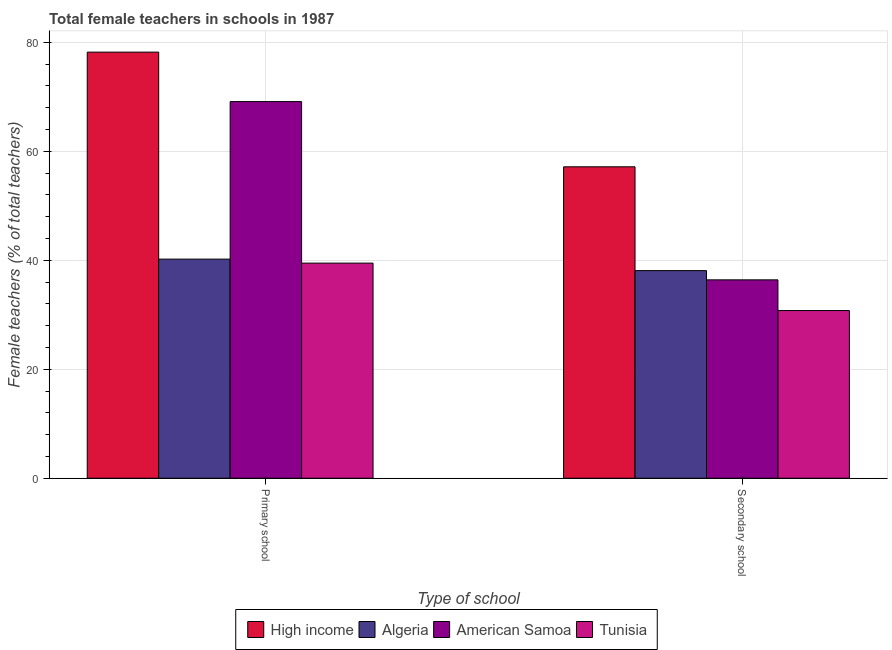Are the number of bars per tick equal to the number of legend labels?
Your response must be concise. Yes. Are the number of bars on each tick of the X-axis equal?
Provide a short and direct response. Yes. How many bars are there on the 2nd tick from the left?
Ensure brevity in your answer.  4. What is the label of the 2nd group of bars from the left?
Offer a very short reply. Secondary school. What is the percentage of female teachers in primary schools in American Samoa?
Your answer should be compact. 69.11. Across all countries, what is the maximum percentage of female teachers in primary schools?
Your answer should be compact. 78.19. Across all countries, what is the minimum percentage of female teachers in primary schools?
Your response must be concise. 39.47. In which country was the percentage of female teachers in secondary schools minimum?
Your response must be concise. Tunisia. What is the total percentage of female teachers in primary schools in the graph?
Keep it short and to the point. 226.98. What is the difference between the percentage of female teachers in secondary schools in Tunisia and that in American Samoa?
Ensure brevity in your answer.  -5.63. What is the difference between the percentage of female teachers in secondary schools in High income and the percentage of female teachers in primary schools in Tunisia?
Your answer should be very brief. 17.67. What is the average percentage of female teachers in primary schools per country?
Provide a short and direct response. 56.75. What is the difference between the percentage of female teachers in secondary schools and percentage of female teachers in primary schools in Algeria?
Your response must be concise. -2.11. What is the ratio of the percentage of female teachers in secondary schools in Algeria to that in Tunisia?
Provide a succinct answer. 1.24. Is the percentage of female teachers in primary schools in American Samoa less than that in High income?
Your answer should be very brief. Yes. What does the 4th bar from the right in Secondary school represents?
Your answer should be compact. High income. What is the difference between two consecutive major ticks on the Y-axis?
Offer a very short reply. 20. Does the graph contain grids?
Offer a terse response. Yes. Where does the legend appear in the graph?
Offer a very short reply. Bottom center. How many legend labels are there?
Your answer should be very brief. 4. How are the legend labels stacked?
Give a very brief answer. Horizontal. What is the title of the graph?
Offer a terse response. Total female teachers in schools in 1987. What is the label or title of the X-axis?
Provide a short and direct response. Type of school. What is the label or title of the Y-axis?
Your answer should be very brief. Female teachers (% of total teachers). What is the Female teachers (% of total teachers) in High income in Primary school?
Provide a short and direct response. 78.19. What is the Female teachers (% of total teachers) in Algeria in Primary school?
Provide a short and direct response. 40.21. What is the Female teachers (% of total teachers) in American Samoa in Primary school?
Provide a succinct answer. 69.11. What is the Female teachers (% of total teachers) in Tunisia in Primary school?
Your answer should be compact. 39.47. What is the Female teachers (% of total teachers) in High income in Secondary school?
Your answer should be compact. 57.15. What is the Female teachers (% of total teachers) of Algeria in Secondary school?
Offer a very short reply. 38.1. What is the Female teachers (% of total teachers) in American Samoa in Secondary school?
Make the answer very short. 36.4. What is the Female teachers (% of total teachers) in Tunisia in Secondary school?
Keep it short and to the point. 30.77. Across all Type of school, what is the maximum Female teachers (% of total teachers) in High income?
Provide a succinct answer. 78.19. Across all Type of school, what is the maximum Female teachers (% of total teachers) in Algeria?
Provide a succinct answer. 40.21. Across all Type of school, what is the maximum Female teachers (% of total teachers) of American Samoa?
Give a very brief answer. 69.11. Across all Type of school, what is the maximum Female teachers (% of total teachers) in Tunisia?
Provide a short and direct response. 39.47. Across all Type of school, what is the minimum Female teachers (% of total teachers) of High income?
Provide a short and direct response. 57.15. Across all Type of school, what is the minimum Female teachers (% of total teachers) of Algeria?
Give a very brief answer. 38.1. Across all Type of school, what is the minimum Female teachers (% of total teachers) in American Samoa?
Your answer should be compact. 36.4. Across all Type of school, what is the minimum Female teachers (% of total teachers) of Tunisia?
Offer a very short reply. 30.77. What is the total Female teachers (% of total teachers) of High income in the graph?
Make the answer very short. 135.34. What is the total Female teachers (% of total teachers) in Algeria in the graph?
Your answer should be compact. 78.3. What is the total Female teachers (% of total teachers) in American Samoa in the graph?
Make the answer very short. 105.52. What is the total Female teachers (% of total teachers) of Tunisia in the graph?
Your response must be concise. 70.24. What is the difference between the Female teachers (% of total teachers) of High income in Primary school and that in Secondary school?
Your answer should be compact. 21.04. What is the difference between the Female teachers (% of total teachers) in Algeria in Primary school and that in Secondary school?
Ensure brevity in your answer.  2.11. What is the difference between the Female teachers (% of total teachers) in American Samoa in Primary school and that in Secondary school?
Offer a very short reply. 32.71. What is the difference between the Female teachers (% of total teachers) in Tunisia in Primary school and that in Secondary school?
Provide a succinct answer. 8.7. What is the difference between the Female teachers (% of total teachers) of High income in Primary school and the Female teachers (% of total teachers) of Algeria in Secondary school?
Provide a succinct answer. 40.09. What is the difference between the Female teachers (% of total teachers) in High income in Primary school and the Female teachers (% of total teachers) in American Samoa in Secondary school?
Offer a terse response. 41.79. What is the difference between the Female teachers (% of total teachers) in High income in Primary school and the Female teachers (% of total teachers) in Tunisia in Secondary school?
Your answer should be very brief. 47.42. What is the difference between the Female teachers (% of total teachers) of Algeria in Primary school and the Female teachers (% of total teachers) of American Samoa in Secondary school?
Your answer should be compact. 3.8. What is the difference between the Female teachers (% of total teachers) of Algeria in Primary school and the Female teachers (% of total teachers) of Tunisia in Secondary school?
Your response must be concise. 9.44. What is the difference between the Female teachers (% of total teachers) of American Samoa in Primary school and the Female teachers (% of total teachers) of Tunisia in Secondary school?
Offer a terse response. 38.34. What is the average Female teachers (% of total teachers) of High income per Type of school?
Provide a succinct answer. 67.67. What is the average Female teachers (% of total teachers) in Algeria per Type of school?
Provide a short and direct response. 39.15. What is the average Female teachers (% of total teachers) of American Samoa per Type of school?
Your answer should be compact. 52.76. What is the average Female teachers (% of total teachers) of Tunisia per Type of school?
Give a very brief answer. 35.12. What is the difference between the Female teachers (% of total teachers) in High income and Female teachers (% of total teachers) in Algeria in Primary school?
Your answer should be very brief. 37.98. What is the difference between the Female teachers (% of total teachers) of High income and Female teachers (% of total teachers) of American Samoa in Primary school?
Make the answer very short. 9.07. What is the difference between the Female teachers (% of total teachers) in High income and Female teachers (% of total teachers) in Tunisia in Primary school?
Offer a terse response. 38.72. What is the difference between the Female teachers (% of total teachers) of Algeria and Female teachers (% of total teachers) of American Samoa in Primary school?
Provide a succinct answer. -28.91. What is the difference between the Female teachers (% of total teachers) of Algeria and Female teachers (% of total teachers) of Tunisia in Primary school?
Your answer should be very brief. 0.73. What is the difference between the Female teachers (% of total teachers) in American Samoa and Female teachers (% of total teachers) in Tunisia in Primary school?
Your response must be concise. 29.64. What is the difference between the Female teachers (% of total teachers) in High income and Female teachers (% of total teachers) in Algeria in Secondary school?
Your answer should be compact. 19.05. What is the difference between the Female teachers (% of total teachers) in High income and Female teachers (% of total teachers) in American Samoa in Secondary school?
Offer a terse response. 20.74. What is the difference between the Female teachers (% of total teachers) in High income and Female teachers (% of total teachers) in Tunisia in Secondary school?
Your response must be concise. 26.38. What is the difference between the Female teachers (% of total teachers) of Algeria and Female teachers (% of total teachers) of American Samoa in Secondary school?
Offer a terse response. 1.69. What is the difference between the Female teachers (% of total teachers) in Algeria and Female teachers (% of total teachers) in Tunisia in Secondary school?
Keep it short and to the point. 7.33. What is the difference between the Female teachers (% of total teachers) in American Samoa and Female teachers (% of total teachers) in Tunisia in Secondary school?
Your answer should be very brief. 5.63. What is the ratio of the Female teachers (% of total teachers) in High income in Primary school to that in Secondary school?
Offer a very short reply. 1.37. What is the ratio of the Female teachers (% of total teachers) of Algeria in Primary school to that in Secondary school?
Provide a succinct answer. 1.06. What is the ratio of the Female teachers (% of total teachers) in American Samoa in Primary school to that in Secondary school?
Offer a very short reply. 1.9. What is the ratio of the Female teachers (% of total teachers) of Tunisia in Primary school to that in Secondary school?
Your answer should be very brief. 1.28. What is the difference between the highest and the second highest Female teachers (% of total teachers) in High income?
Your answer should be compact. 21.04. What is the difference between the highest and the second highest Female teachers (% of total teachers) of Algeria?
Provide a succinct answer. 2.11. What is the difference between the highest and the second highest Female teachers (% of total teachers) of American Samoa?
Give a very brief answer. 32.71. What is the difference between the highest and the second highest Female teachers (% of total teachers) of Tunisia?
Keep it short and to the point. 8.7. What is the difference between the highest and the lowest Female teachers (% of total teachers) of High income?
Offer a terse response. 21.04. What is the difference between the highest and the lowest Female teachers (% of total teachers) in Algeria?
Ensure brevity in your answer.  2.11. What is the difference between the highest and the lowest Female teachers (% of total teachers) in American Samoa?
Keep it short and to the point. 32.71. What is the difference between the highest and the lowest Female teachers (% of total teachers) of Tunisia?
Ensure brevity in your answer.  8.7. 